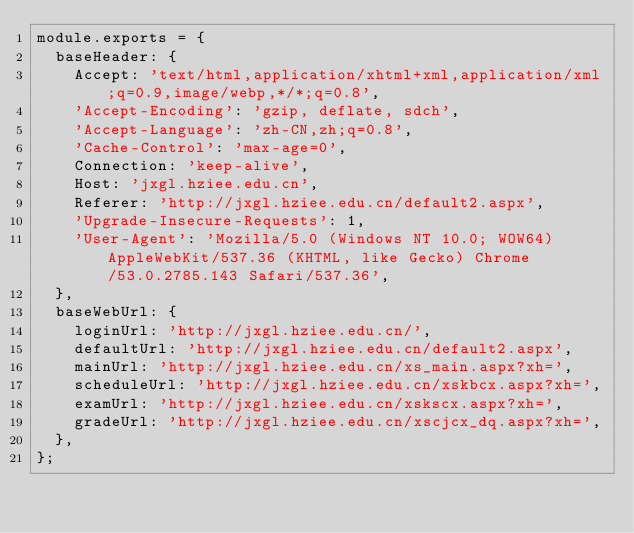Convert code to text. <code><loc_0><loc_0><loc_500><loc_500><_JavaScript_>module.exports = {
  baseHeader: {
    Accept: 'text/html,application/xhtml+xml,application/xml;q=0.9,image/webp,*/*;q=0.8',
    'Accept-Encoding': 'gzip, deflate, sdch',
    'Accept-Language': 'zh-CN,zh;q=0.8',
    'Cache-Control': 'max-age=0',
    Connection: 'keep-alive',
    Host: 'jxgl.hziee.edu.cn',
    Referer: 'http://jxgl.hziee.edu.cn/default2.aspx',
    'Upgrade-Insecure-Requests': 1,
    'User-Agent': 'Mozilla/5.0 (Windows NT 10.0; WOW64) AppleWebKit/537.36 (KHTML, like Gecko) Chrome/53.0.2785.143 Safari/537.36',
  },
  baseWebUrl: {
    loginUrl: 'http://jxgl.hziee.edu.cn/',
    defaultUrl: 'http://jxgl.hziee.edu.cn/default2.aspx',
    mainUrl: 'http://jxgl.hziee.edu.cn/xs_main.aspx?xh=',
    scheduleUrl: 'http://jxgl.hziee.edu.cn/xskbcx.aspx?xh=',
    examUrl: 'http://jxgl.hziee.edu.cn/xskscx.aspx?xh=',
    gradeUrl: 'http://jxgl.hziee.edu.cn/xscjcx_dq.aspx?xh=',
  },
};
</code> 